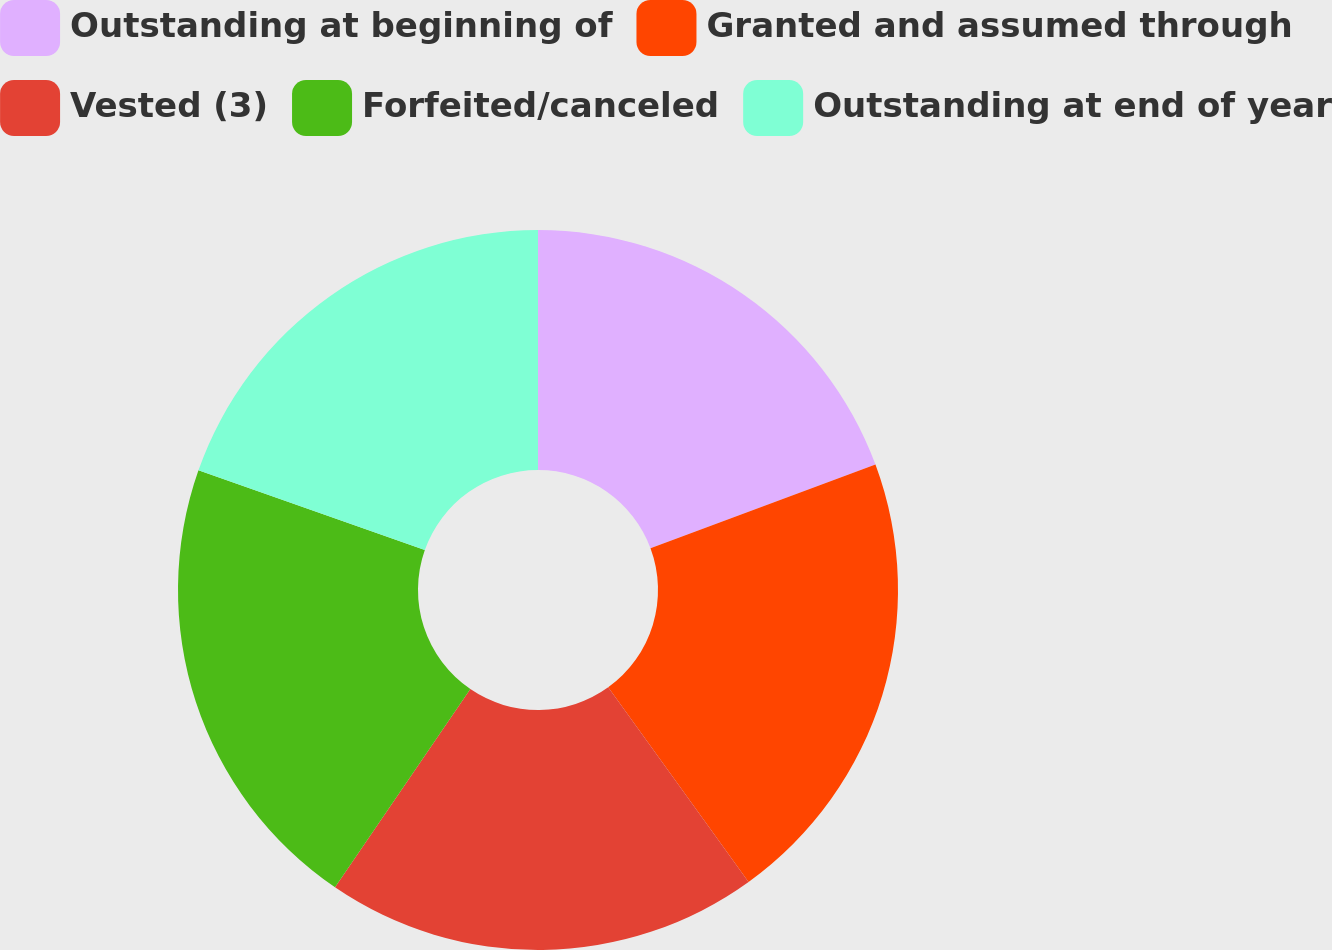Convert chart. <chart><loc_0><loc_0><loc_500><loc_500><pie_chart><fcel>Outstanding at beginning of<fcel>Granted and assumed through<fcel>Vested (3)<fcel>Forfeited/canceled<fcel>Outstanding at end of year<nl><fcel>19.34%<fcel>20.72%<fcel>19.48%<fcel>20.86%<fcel>19.61%<nl></chart> 